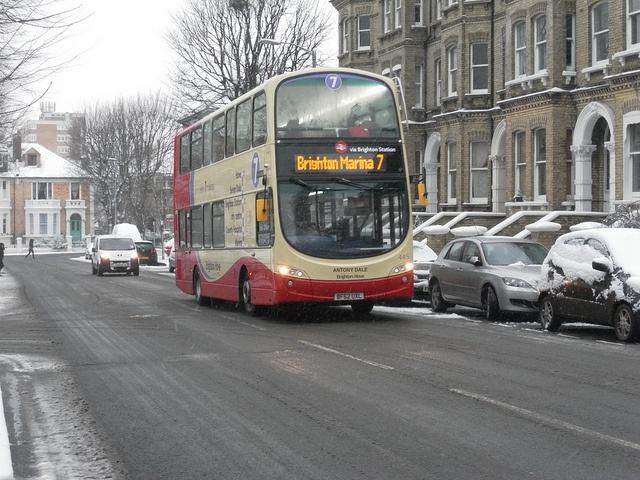Describe the objects in this image and their specific colors. I can see bus in lightgray, gray, darkgray, and black tones, car in lightgray, black, gray, and darkgray tones, car in lightgray, gray, darkgray, and black tones, car in lightgray, darkgray, gray, and black tones, and car in lightgray, darkgray, gray, and black tones in this image. 